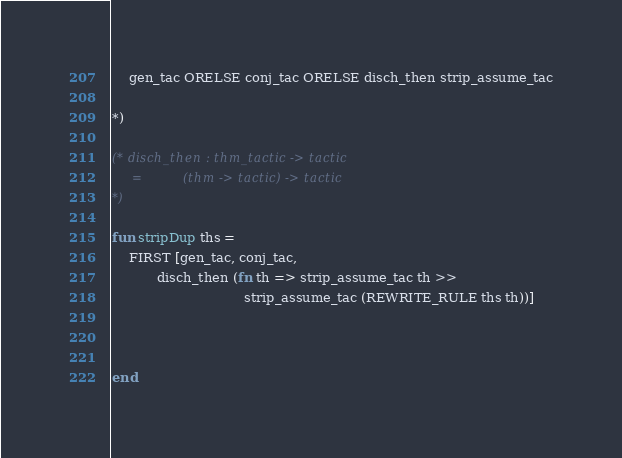<code> <loc_0><loc_0><loc_500><loc_500><_SML_>    gen_tac ORELSE conj_tac ORELSE disch_then strip_assume_tac

*)

(* disch_then : thm_tactic -> tactic
     =          (thm -> tactic) -> tactic
*)

fun stripDup ths =
    FIRST [gen_tac, conj_tac,
           disch_then (fn th => strip_assume_tac th >>
                                strip_assume_tac (REWRITE_RULE ths th))]



end</code> 